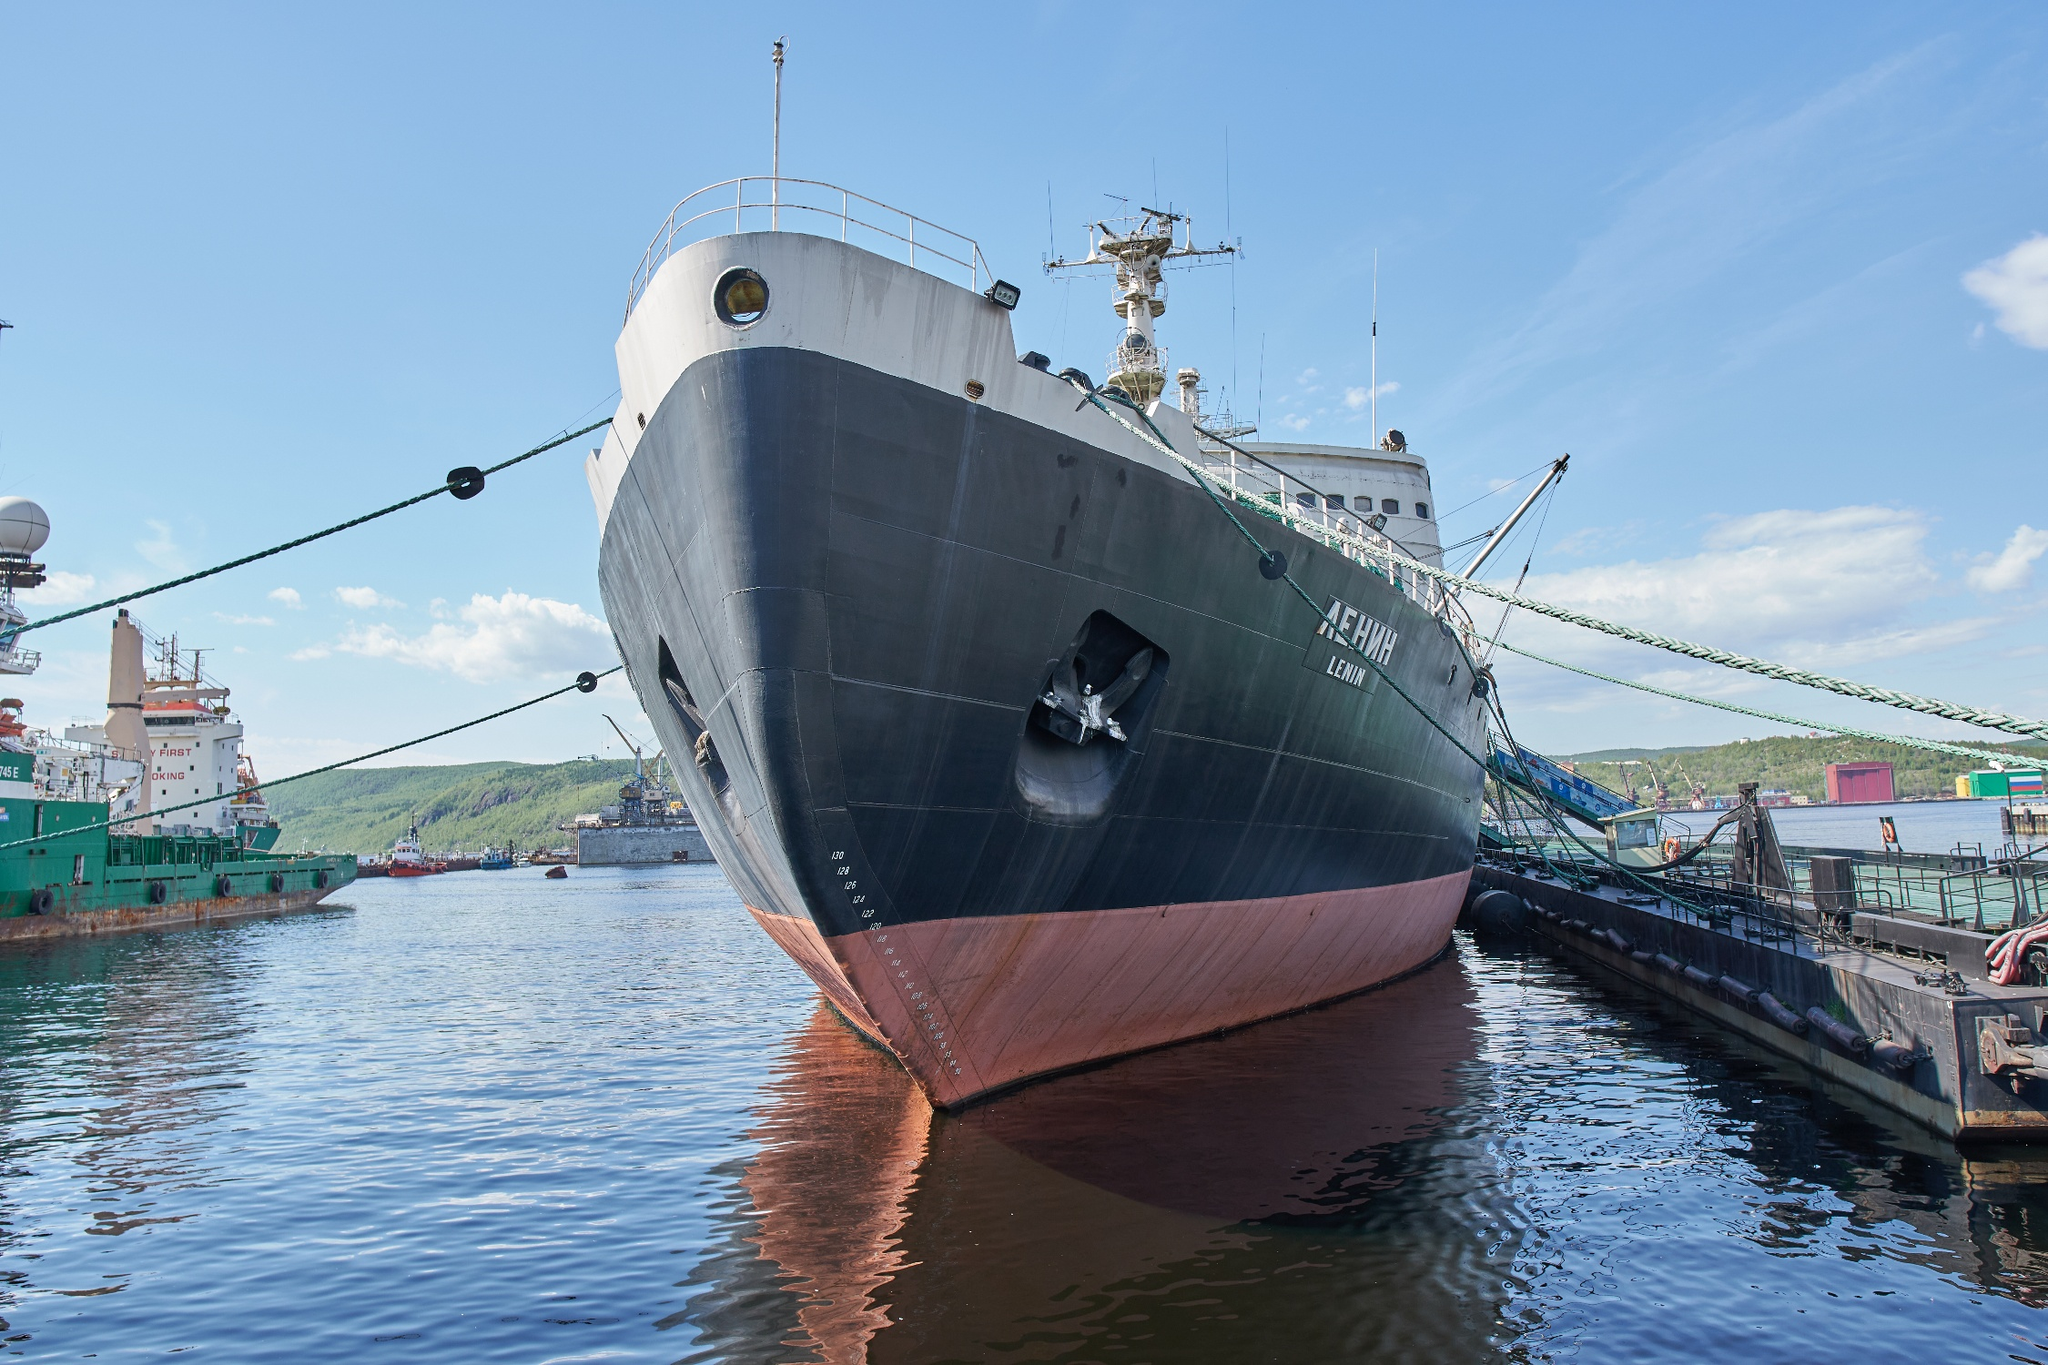If this ship could tell a story, what would it say about its journeys? If the Lenin could tell a story, it would speak of braving the formidable Arctic ice, navigating through treacherous waters to ensure safe passage for other vessels. It would recall the myriad of voyages where it broke through thick ice layers, the serene yet hostile beauty of the Arctic, and the camaraderie formed among its crew. Each expedition would be a testament to human ingenuity and determination to conquer nature's toughest challenges. The ship would also remember the awe and pride of being the first nuclear-powered icebreaker, pioneering a future for ice navigation, and ultimately, its transition into a symbol of historical significance and technological marvel. 